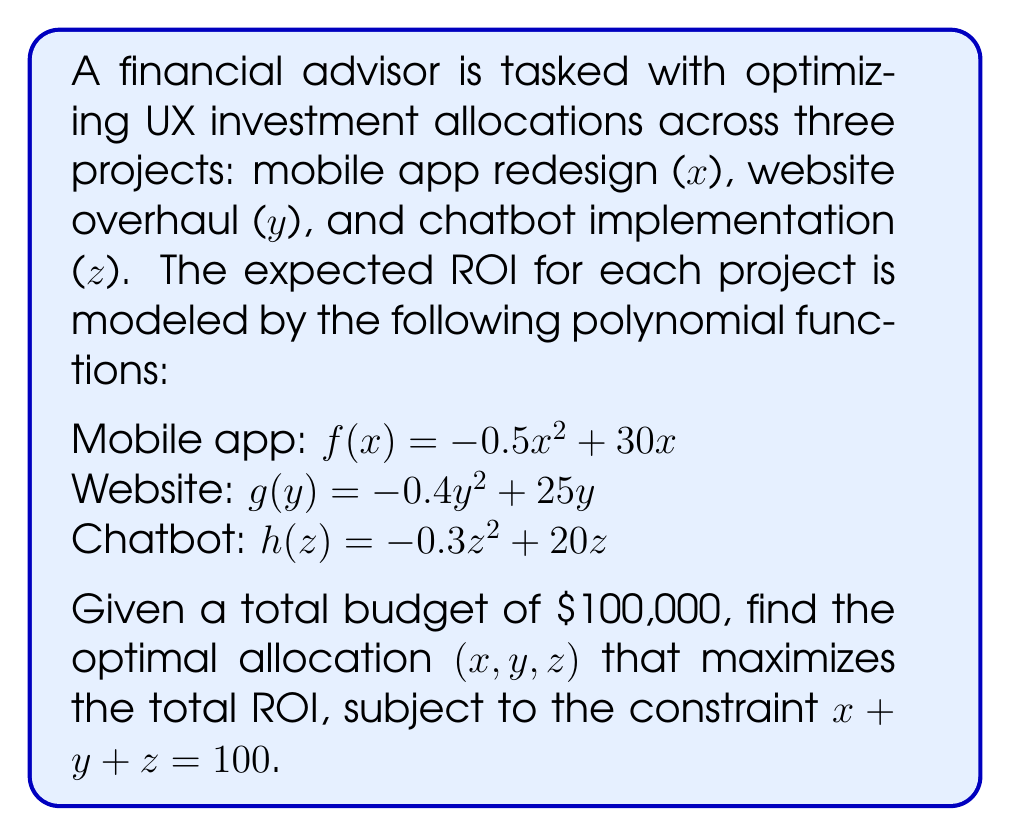Give your solution to this math problem. To solve this optimization problem, we'll use the method of Lagrange multipliers:

1. Define the objective function:
   $L(x, y, z, λ) = f(x) + g(y) + h(z) + λ(100 - x - y - z)$

2. Take partial derivatives and set them equal to zero:
   $\frac{\partial L}{\partial x} = -x + 30 - λ = 0$
   $\frac{\partial L}{\partial y} = -0.8y + 25 - λ = 0$
   $\frac{\partial L}{\partial z} = -0.6z + 20 - λ = 0$
   $\frac{\partial L}{\partial λ} = 100 - x - y - z = 0$

3. Solve the system of equations:
   From the first three equations:
   $x = 30 - λ$
   $y = \frac{25 - λ}{0.8} = 31.25 - 1.25λ$
   $z = \frac{20 - λ}{0.6} = 33.33 - 1.67λ$

   Substitute these into the fourth equation:
   $100 = (30 - λ) + (31.25 - 1.25λ) + (33.33 - 1.67λ)$
   $100 = 94.58 - 3.92λ$
   $5.42 = 3.92λ$
   $λ = 1.38$

4. Calculate the optimal values:
   $x = 30 - 1.38 = 28.62$
   $y = 31.25 - 1.25(1.38) = 29.52$
   $z = 33.33 - 1.67(1.38) = 31.03$

5. Round to the nearest thousand (as we're dealing with dollars):
   $x ≈ 29,000$
   $y ≈ 30,000$
   $z ≈ 31,000$

6. Verify the constraint:
   $29,000 + 30,000 + 31,000 = 90,000$

The optimal allocation is approximately $29,000 for the mobile app redesign, $30,000 for the website overhaul, and $31,000 for the chatbot implementation.
Answer: The optimal investment allocation is approximately:
Mobile app redesign (x): $29,000
Website overhaul (y): $30,000
Chatbot implementation (z): $31,000 